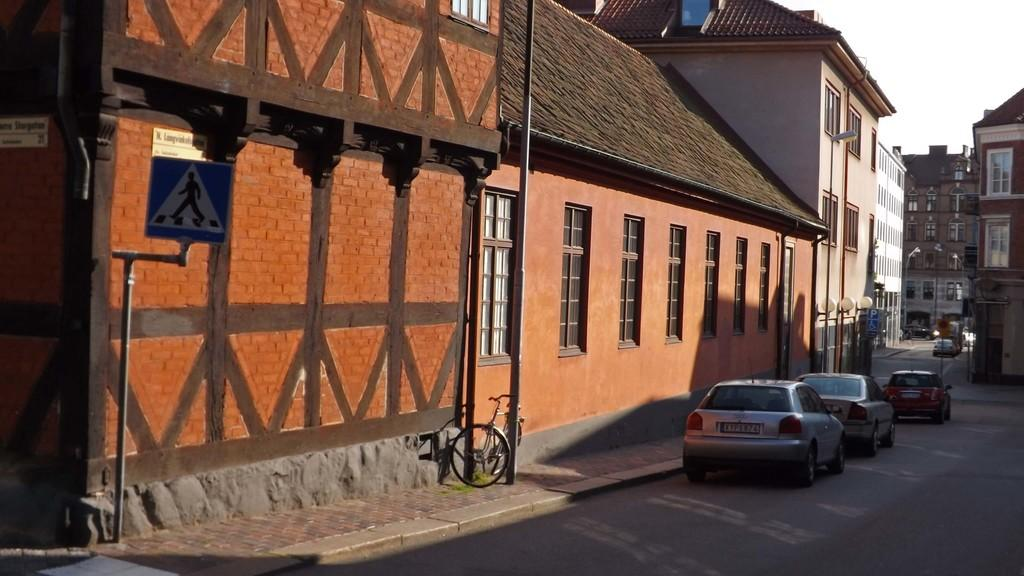What can be seen on the right side of the image? There are vehicles on the road on the right side of the image. What is visible in the background of the image? Buildings, light poles, sign board poles, windows, and roofs are visible in the background of the image. Can you describe the object on the footpath in the background? There is a bicycle on the footpath at a pole in the background of the image. What type of meat is hanging from the light poles in the image? There is no meat hanging from the light poles in the image; light poles are present in the background, but no meat is mentioned in the facts. Where are the dolls located in the image? There is no mention of dolls in the image, so we cannot determine their location. 